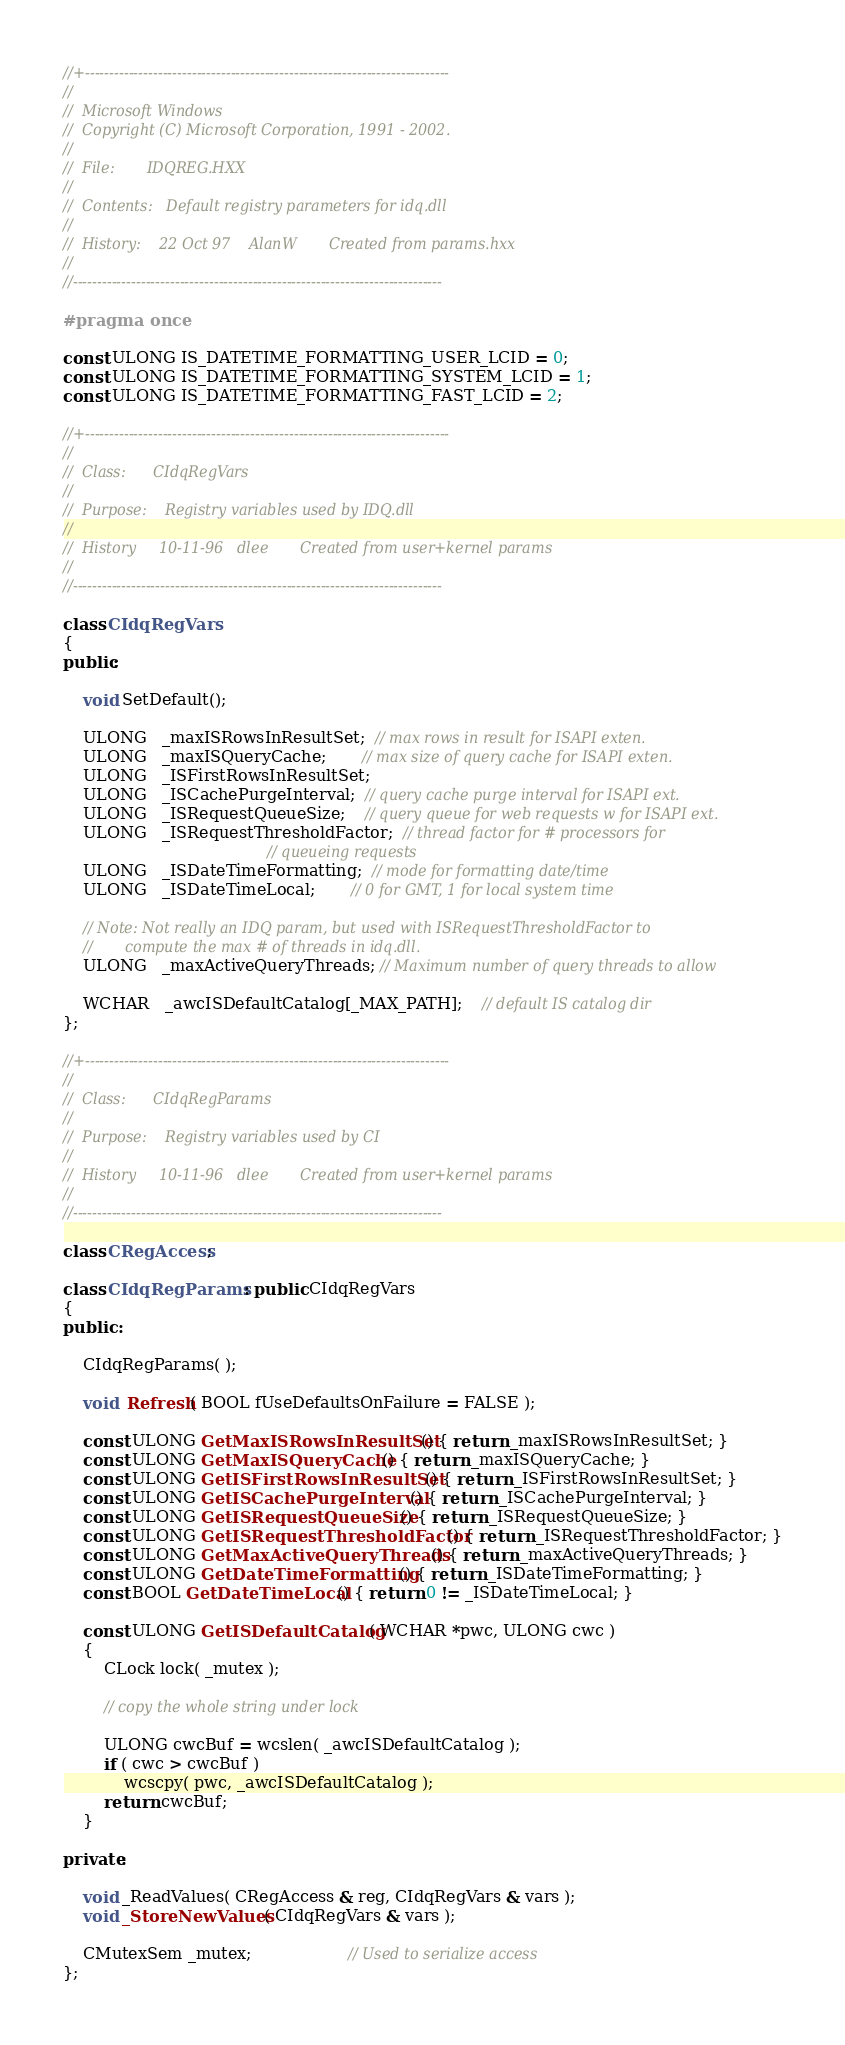Convert code to text. <code><loc_0><loc_0><loc_500><loc_500><_C++_>//+---------------------------------------------------------------------------
//
//  Microsoft Windows
//  Copyright (C) Microsoft Corporation, 1991 - 2002.
//
//  File:       IDQREG.HXX
//
//  Contents:   Default registry parameters for idq.dll
//
//  History:    22 Oct 97    AlanW       Created from params.hxx
//
//----------------------------------------------------------------------------

#pragma once

const ULONG IS_DATETIME_FORMATTING_USER_LCID = 0;
const ULONG IS_DATETIME_FORMATTING_SYSTEM_LCID = 1;
const ULONG IS_DATETIME_FORMATTING_FAST_LCID = 2;

//+---------------------------------------------------------------------------
//
//  Class:      CIdqRegVars
//
//  Purpose:    Registry variables used by IDQ.dll
//
//  History     10-11-96   dlee       Created from user+kernel params
//
//----------------------------------------------------------------------------

class CIdqRegVars
{
public:

    void SetDefault();

    ULONG   _maxISRowsInResultSet;  // max rows in result for ISAPI exten.
    ULONG   _maxISQueryCache;       // max size of query cache for ISAPI exten.
    ULONG   _ISFirstRowsInResultSet;
    ULONG   _ISCachePurgeInterval;  // query cache purge interval for ISAPI ext.
    ULONG   _ISRequestQueueSize;    // query queue for web requests w for ISAPI ext.
    ULONG   _ISRequestThresholdFactor;  // thread factor for # processors for
                                        // queueing requests
    ULONG   _ISDateTimeFormatting;  // mode for formatting date/time
    ULONG   _ISDateTimeLocal;       // 0 for GMT, 1 for local system time

    // Note: Not really an IDQ param, but used with ISRequestThresholdFactor to
    //       compute the max # of threads in idq.dll.
    ULONG   _maxActiveQueryThreads; // Maximum number of query threads to allow

    WCHAR   _awcISDefaultCatalog[_MAX_PATH];    // default IS catalog dir
};

//+---------------------------------------------------------------------------
//
//  Class:      CIdqRegParams
//
//  Purpose:    Registry variables used by CI
//
//  History     10-11-96   dlee       Created from user+kernel params
//
//----------------------------------------------------------------------------

class CRegAccess;

class CIdqRegParams : public CIdqRegVars
{
public :

    CIdqRegParams( );

    void  Refresh( BOOL fUseDefaultsOnFailure = FALSE );

    const ULONG GetMaxISRowsInResultSet() { return _maxISRowsInResultSet; }
    const ULONG GetMaxISQueryCache() { return _maxISQueryCache; }
    const ULONG GetISFirstRowsInResultSet() { return _ISFirstRowsInResultSet; }
    const ULONG GetISCachePurgeInterval() { return _ISCachePurgeInterval; }
    const ULONG GetISRequestQueueSize() { return _ISRequestQueueSize; }
    const ULONG GetISRequestThresholdFactor() { return _ISRequestThresholdFactor; }
    const ULONG GetMaxActiveQueryThreads() { return _maxActiveQueryThreads; }
    const ULONG GetDateTimeFormatting() { return _ISDateTimeFormatting; }
    const BOOL GetDateTimeLocal() { return 0 != _ISDateTimeLocal; }

    const ULONG GetISDefaultCatalog( WCHAR *pwc, ULONG cwc )
    {
        CLock lock( _mutex );

        // copy the whole string under lock

        ULONG cwcBuf = wcslen( _awcISDefaultCatalog );
        if ( cwc > cwcBuf )
            wcscpy( pwc, _awcISDefaultCatalog );
        return cwcBuf;
    }

private:

    void _ReadValues( CRegAccess & reg, CIdqRegVars & vars );
    void _StoreNewValues( CIdqRegVars & vars );

    CMutexSem _mutex;                   // Used to serialize access
};

</code> 